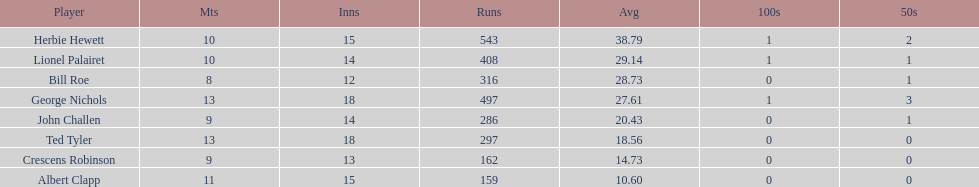What was the total number of runs ted tyler scored? 297. 